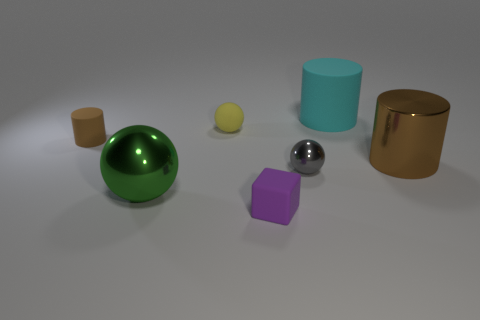Is the metal cylinder the same color as the small cylinder?
Ensure brevity in your answer.  Yes. How big is the purple matte thing in front of the cylinder in front of the brown thing to the left of the big shiny cylinder?
Your answer should be very brief. Small. How big is the shiny thing that is in front of the big brown metallic cylinder and behind the large green metallic object?
Your response must be concise. Small. There is a big brown thing that is the same shape as the large cyan thing; what is it made of?
Give a very brief answer. Metal. The brown object on the right side of the large thing that is left of the matte cube is made of what material?
Keep it short and to the point. Metal. There is a small gray metal thing; does it have the same shape as the large object that is in front of the brown metal cylinder?
Provide a succinct answer. Yes. How many shiny objects are yellow objects or small red balls?
Provide a succinct answer. 0. What color is the big thing in front of the tiny sphere that is on the right side of the yellow rubber thing that is behind the brown rubber cylinder?
Keep it short and to the point. Green. What number of other things are there of the same material as the tiny cylinder
Offer a very short reply. 3. There is a large metal object on the left side of the large cyan rubber object; does it have the same shape as the brown metallic object?
Keep it short and to the point. No. 